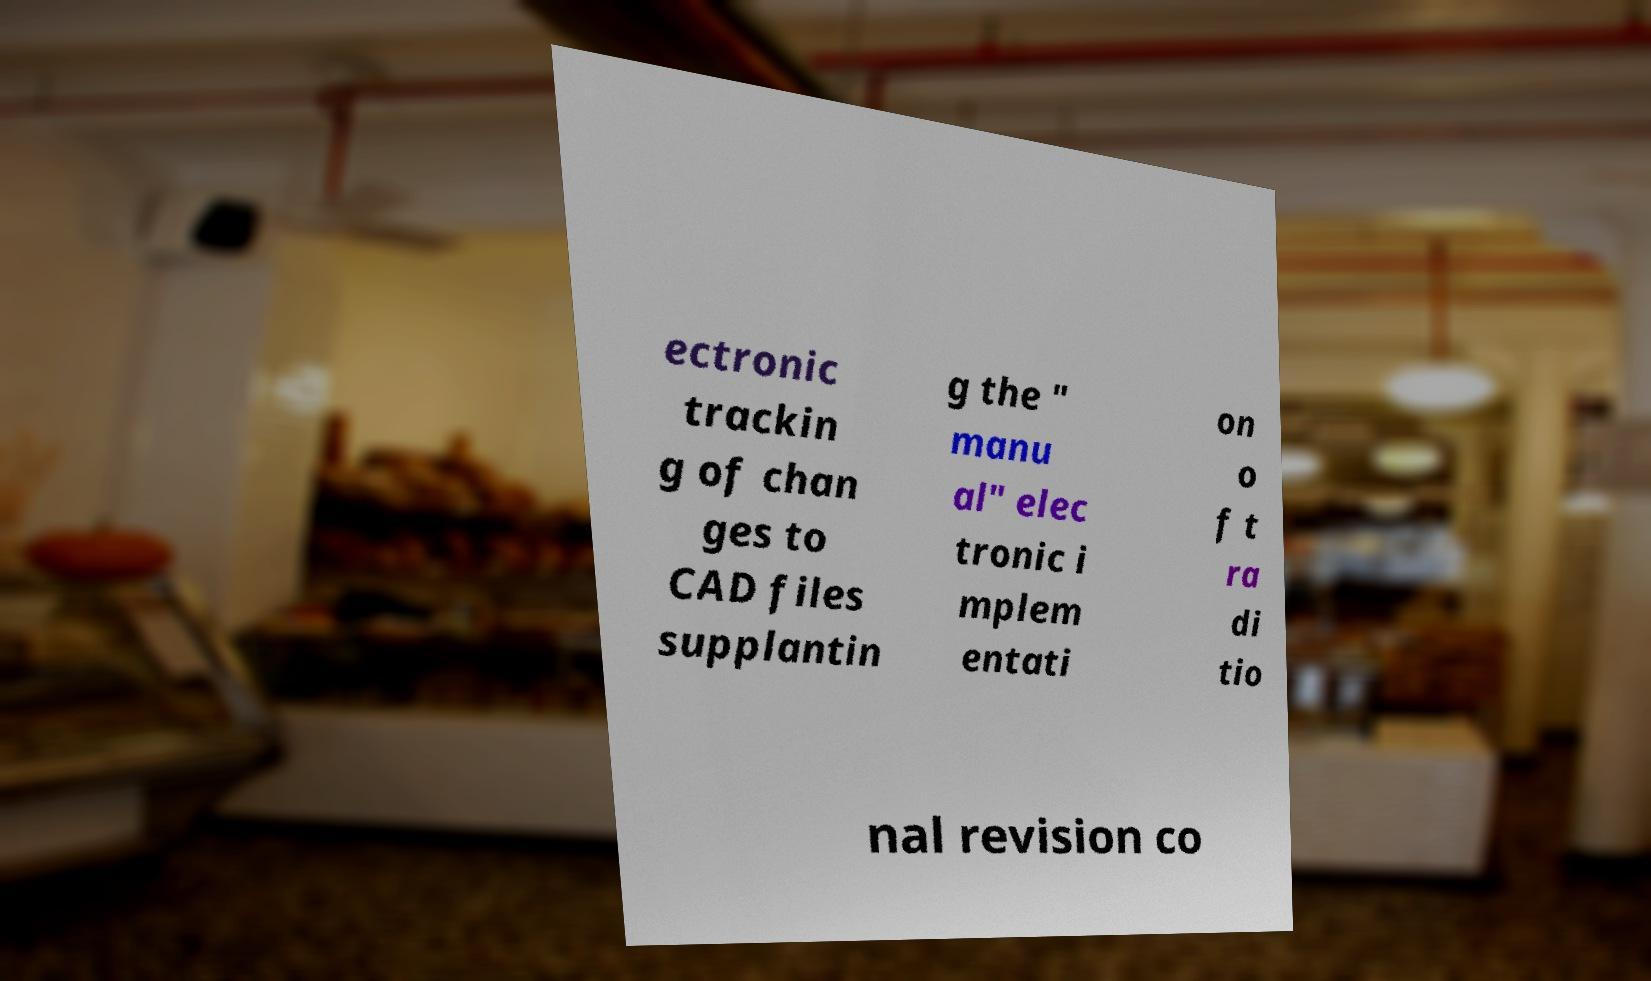Please identify and transcribe the text found in this image. ectronic trackin g of chan ges to CAD files supplantin g the " manu al" elec tronic i mplem entati on o f t ra di tio nal revision co 